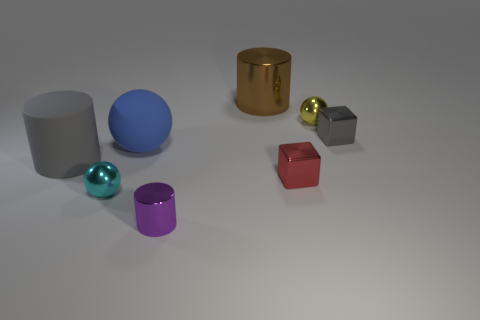Can you tell me the different colors of the objects present in the image? Certainly! The objects in the image consist of a variety of colors: there's a blue sphere, a silver cylinder, a gold cylinder, a turquoise metallic ball, a grey cube, a red cube, and a purple cylinder. 